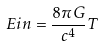Convert formula to latex. <formula><loc_0><loc_0><loc_500><loc_500>E i n = \frac { 8 \pi G } { c ^ { 4 } } T</formula> 